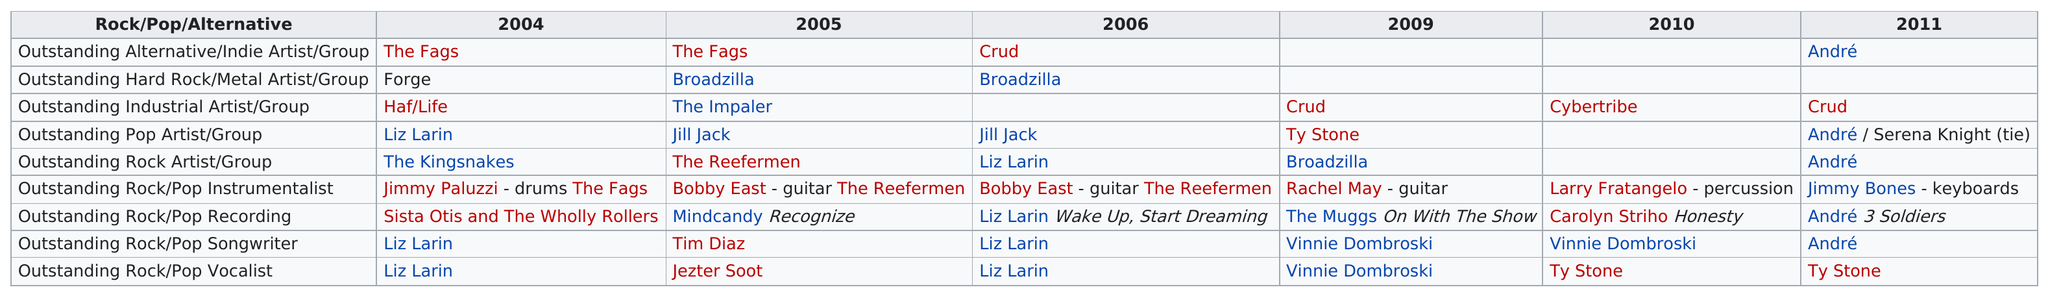Mention a couple of crucial points in this snapshot. The artist known as Jill Jack had a series of consecutive wins in the Outstanding Pop Artist/Group category. Vincent Dombrowski won for 2 years. In 1990, Jill Jack won the award for Outstanding Pop Artist/Group, while The Reefermen won in the category of Outstanding Rock Artist/Group. Vincent Dombrowski won an award in 2010. After 2005, a total of three different songwriters won the Outstanding Rock/Pop Songwriter award. 